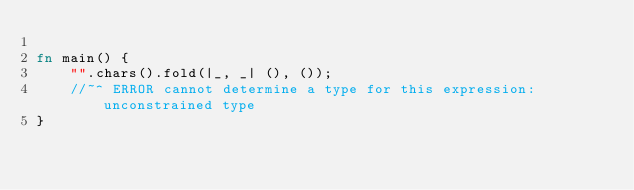<code> <loc_0><loc_0><loc_500><loc_500><_Rust_>
fn main() {
    "".chars().fold(|_, _| (), ());
    //~^ ERROR cannot determine a type for this expression: unconstrained type
}
</code> 